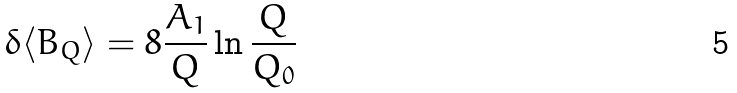<formula> <loc_0><loc_0><loc_500><loc_500>\delta \langle B _ { Q } \rangle = 8 \frac { A _ { 1 } } { Q } \ln { \frac { Q } { Q _ { 0 } } }</formula> 